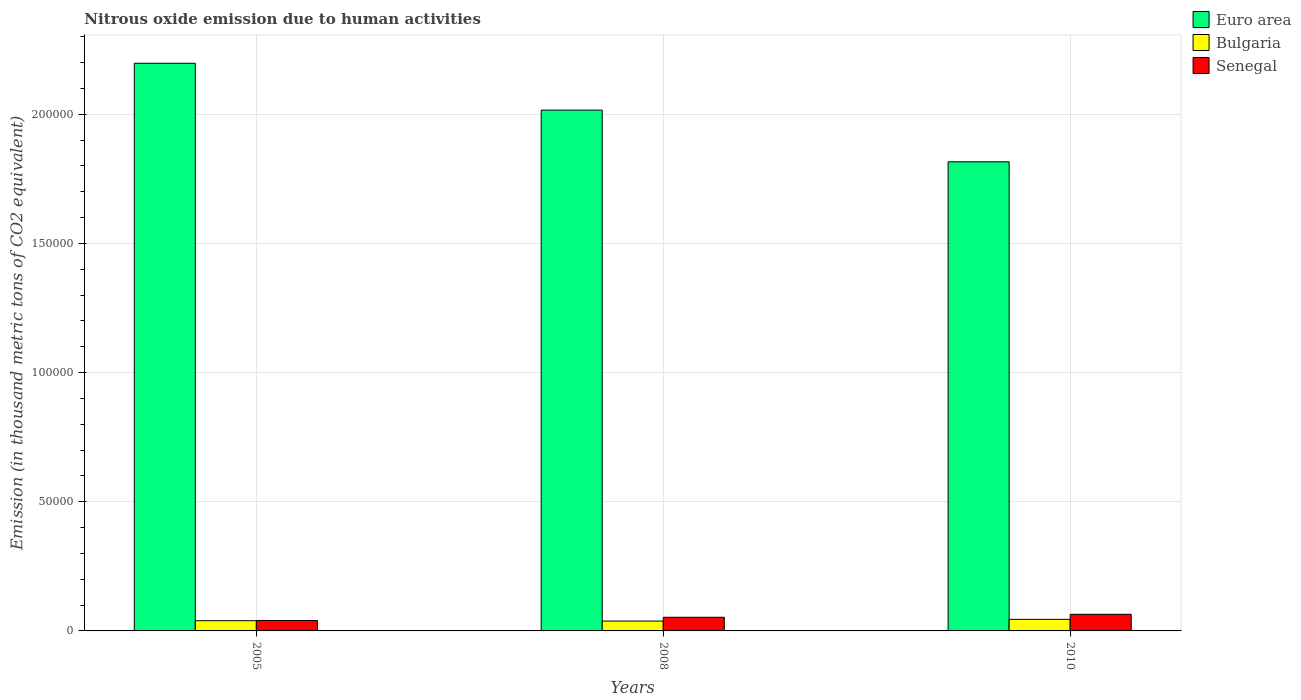Are the number of bars per tick equal to the number of legend labels?
Your response must be concise. Yes. Are the number of bars on each tick of the X-axis equal?
Make the answer very short. Yes. What is the label of the 2nd group of bars from the left?
Make the answer very short. 2008. What is the amount of nitrous oxide emitted in Bulgaria in 2008?
Offer a very short reply. 3815.2. Across all years, what is the maximum amount of nitrous oxide emitted in Senegal?
Offer a very short reply. 6433. Across all years, what is the minimum amount of nitrous oxide emitted in Senegal?
Give a very brief answer. 4042.4. What is the total amount of nitrous oxide emitted in Senegal in the graph?
Your answer should be very brief. 1.58e+04. What is the difference between the amount of nitrous oxide emitted in Euro area in 2005 and that in 2010?
Your answer should be very brief. 3.82e+04. What is the difference between the amount of nitrous oxide emitted in Bulgaria in 2008 and the amount of nitrous oxide emitted in Senegal in 2010?
Give a very brief answer. -2617.8. What is the average amount of nitrous oxide emitted in Senegal per year?
Offer a very short reply. 5252.03. In the year 2010, what is the difference between the amount of nitrous oxide emitted in Senegal and amount of nitrous oxide emitted in Euro area?
Your response must be concise. -1.75e+05. What is the ratio of the amount of nitrous oxide emitted in Bulgaria in 2008 to that in 2010?
Provide a succinct answer. 0.85. What is the difference between the highest and the second highest amount of nitrous oxide emitted in Euro area?
Give a very brief answer. 1.81e+04. What is the difference between the highest and the lowest amount of nitrous oxide emitted in Euro area?
Offer a terse response. 3.82e+04. In how many years, is the amount of nitrous oxide emitted in Bulgaria greater than the average amount of nitrous oxide emitted in Bulgaria taken over all years?
Keep it short and to the point. 1. Is the sum of the amount of nitrous oxide emitted in Euro area in 2005 and 2008 greater than the maximum amount of nitrous oxide emitted in Senegal across all years?
Offer a very short reply. Yes. What does the 1st bar from the right in 2008 represents?
Keep it short and to the point. Senegal. Is it the case that in every year, the sum of the amount of nitrous oxide emitted in Bulgaria and amount of nitrous oxide emitted in Senegal is greater than the amount of nitrous oxide emitted in Euro area?
Give a very brief answer. No. Are all the bars in the graph horizontal?
Make the answer very short. No. How many years are there in the graph?
Provide a short and direct response. 3. Where does the legend appear in the graph?
Offer a very short reply. Top right. How are the legend labels stacked?
Offer a terse response. Vertical. What is the title of the graph?
Offer a terse response. Nitrous oxide emission due to human activities. Does "Canada" appear as one of the legend labels in the graph?
Your response must be concise. No. What is the label or title of the Y-axis?
Offer a terse response. Emission (in thousand metric tons of CO2 equivalent). What is the Emission (in thousand metric tons of CO2 equivalent) in Euro area in 2005?
Ensure brevity in your answer.  2.20e+05. What is the Emission (in thousand metric tons of CO2 equivalent) of Bulgaria in 2005?
Offer a very short reply. 3951.9. What is the Emission (in thousand metric tons of CO2 equivalent) in Senegal in 2005?
Provide a succinct answer. 4042.4. What is the Emission (in thousand metric tons of CO2 equivalent) of Euro area in 2008?
Offer a very short reply. 2.02e+05. What is the Emission (in thousand metric tons of CO2 equivalent) of Bulgaria in 2008?
Offer a very short reply. 3815.2. What is the Emission (in thousand metric tons of CO2 equivalent) in Senegal in 2008?
Provide a succinct answer. 5280.7. What is the Emission (in thousand metric tons of CO2 equivalent) in Euro area in 2010?
Your answer should be compact. 1.82e+05. What is the Emission (in thousand metric tons of CO2 equivalent) of Bulgaria in 2010?
Keep it short and to the point. 4479.2. What is the Emission (in thousand metric tons of CO2 equivalent) in Senegal in 2010?
Make the answer very short. 6433. Across all years, what is the maximum Emission (in thousand metric tons of CO2 equivalent) of Euro area?
Provide a short and direct response. 2.20e+05. Across all years, what is the maximum Emission (in thousand metric tons of CO2 equivalent) in Bulgaria?
Your answer should be compact. 4479.2. Across all years, what is the maximum Emission (in thousand metric tons of CO2 equivalent) of Senegal?
Provide a short and direct response. 6433. Across all years, what is the minimum Emission (in thousand metric tons of CO2 equivalent) of Euro area?
Offer a terse response. 1.82e+05. Across all years, what is the minimum Emission (in thousand metric tons of CO2 equivalent) of Bulgaria?
Offer a terse response. 3815.2. Across all years, what is the minimum Emission (in thousand metric tons of CO2 equivalent) in Senegal?
Provide a succinct answer. 4042.4. What is the total Emission (in thousand metric tons of CO2 equivalent) of Euro area in the graph?
Make the answer very short. 6.03e+05. What is the total Emission (in thousand metric tons of CO2 equivalent) in Bulgaria in the graph?
Keep it short and to the point. 1.22e+04. What is the total Emission (in thousand metric tons of CO2 equivalent) in Senegal in the graph?
Provide a succinct answer. 1.58e+04. What is the difference between the Emission (in thousand metric tons of CO2 equivalent) in Euro area in 2005 and that in 2008?
Provide a succinct answer. 1.81e+04. What is the difference between the Emission (in thousand metric tons of CO2 equivalent) in Bulgaria in 2005 and that in 2008?
Your response must be concise. 136.7. What is the difference between the Emission (in thousand metric tons of CO2 equivalent) in Senegal in 2005 and that in 2008?
Ensure brevity in your answer.  -1238.3. What is the difference between the Emission (in thousand metric tons of CO2 equivalent) of Euro area in 2005 and that in 2010?
Keep it short and to the point. 3.82e+04. What is the difference between the Emission (in thousand metric tons of CO2 equivalent) in Bulgaria in 2005 and that in 2010?
Ensure brevity in your answer.  -527.3. What is the difference between the Emission (in thousand metric tons of CO2 equivalent) of Senegal in 2005 and that in 2010?
Ensure brevity in your answer.  -2390.6. What is the difference between the Emission (in thousand metric tons of CO2 equivalent) in Euro area in 2008 and that in 2010?
Your answer should be very brief. 2.00e+04. What is the difference between the Emission (in thousand metric tons of CO2 equivalent) in Bulgaria in 2008 and that in 2010?
Ensure brevity in your answer.  -664. What is the difference between the Emission (in thousand metric tons of CO2 equivalent) of Senegal in 2008 and that in 2010?
Provide a short and direct response. -1152.3. What is the difference between the Emission (in thousand metric tons of CO2 equivalent) in Euro area in 2005 and the Emission (in thousand metric tons of CO2 equivalent) in Bulgaria in 2008?
Make the answer very short. 2.16e+05. What is the difference between the Emission (in thousand metric tons of CO2 equivalent) of Euro area in 2005 and the Emission (in thousand metric tons of CO2 equivalent) of Senegal in 2008?
Provide a succinct answer. 2.14e+05. What is the difference between the Emission (in thousand metric tons of CO2 equivalent) of Bulgaria in 2005 and the Emission (in thousand metric tons of CO2 equivalent) of Senegal in 2008?
Make the answer very short. -1328.8. What is the difference between the Emission (in thousand metric tons of CO2 equivalent) of Euro area in 2005 and the Emission (in thousand metric tons of CO2 equivalent) of Bulgaria in 2010?
Your answer should be very brief. 2.15e+05. What is the difference between the Emission (in thousand metric tons of CO2 equivalent) in Euro area in 2005 and the Emission (in thousand metric tons of CO2 equivalent) in Senegal in 2010?
Offer a terse response. 2.13e+05. What is the difference between the Emission (in thousand metric tons of CO2 equivalent) of Bulgaria in 2005 and the Emission (in thousand metric tons of CO2 equivalent) of Senegal in 2010?
Your response must be concise. -2481.1. What is the difference between the Emission (in thousand metric tons of CO2 equivalent) of Euro area in 2008 and the Emission (in thousand metric tons of CO2 equivalent) of Bulgaria in 2010?
Keep it short and to the point. 1.97e+05. What is the difference between the Emission (in thousand metric tons of CO2 equivalent) of Euro area in 2008 and the Emission (in thousand metric tons of CO2 equivalent) of Senegal in 2010?
Keep it short and to the point. 1.95e+05. What is the difference between the Emission (in thousand metric tons of CO2 equivalent) of Bulgaria in 2008 and the Emission (in thousand metric tons of CO2 equivalent) of Senegal in 2010?
Offer a terse response. -2617.8. What is the average Emission (in thousand metric tons of CO2 equivalent) in Euro area per year?
Provide a short and direct response. 2.01e+05. What is the average Emission (in thousand metric tons of CO2 equivalent) in Bulgaria per year?
Provide a short and direct response. 4082.1. What is the average Emission (in thousand metric tons of CO2 equivalent) in Senegal per year?
Give a very brief answer. 5252.03. In the year 2005, what is the difference between the Emission (in thousand metric tons of CO2 equivalent) in Euro area and Emission (in thousand metric tons of CO2 equivalent) in Bulgaria?
Provide a succinct answer. 2.16e+05. In the year 2005, what is the difference between the Emission (in thousand metric tons of CO2 equivalent) of Euro area and Emission (in thousand metric tons of CO2 equivalent) of Senegal?
Provide a succinct answer. 2.16e+05. In the year 2005, what is the difference between the Emission (in thousand metric tons of CO2 equivalent) of Bulgaria and Emission (in thousand metric tons of CO2 equivalent) of Senegal?
Your answer should be very brief. -90.5. In the year 2008, what is the difference between the Emission (in thousand metric tons of CO2 equivalent) in Euro area and Emission (in thousand metric tons of CO2 equivalent) in Bulgaria?
Give a very brief answer. 1.98e+05. In the year 2008, what is the difference between the Emission (in thousand metric tons of CO2 equivalent) in Euro area and Emission (in thousand metric tons of CO2 equivalent) in Senegal?
Offer a very short reply. 1.96e+05. In the year 2008, what is the difference between the Emission (in thousand metric tons of CO2 equivalent) in Bulgaria and Emission (in thousand metric tons of CO2 equivalent) in Senegal?
Keep it short and to the point. -1465.5. In the year 2010, what is the difference between the Emission (in thousand metric tons of CO2 equivalent) of Euro area and Emission (in thousand metric tons of CO2 equivalent) of Bulgaria?
Provide a succinct answer. 1.77e+05. In the year 2010, what is the difference between the Emission (in thousand metric tons of CO2 equivalent) of Euro area and Emission (in thousand metric tons of CO2 equivalent) of Senegal?
Make the answer very short. 1.75e+05. In the year 2010, what is the difference between the Emission (in thousand metric tons of CO2 equivalent) in Bulgaria and Emission (in thousand metric tons of CO2 equivalent) in Senegal?
Provide a short and direct response. -1953.8. What is the ratio of the Emission (in thousand metric tons of CO2 equivalent) of Euro area in 2005 to that in 2008?
Keep it short and to the point. 1.09. What is the ratio of the Emission (in thousand metric tons of CO2 equivalent) of Bulgaria in 2005 to that in 2008?
Offer a terse response. 1.04. What is the ratio of the Emission (in thousand metric tons of CO2 equivalent) of Senegal in 2005 to that in 2008?
Keep it short and to the point. 0.77. What is the ratio of the Emission (in thousand metric tons of CO2 equivalent) in Euro area in 2005 to that in 2010?
Make the answer very short. 1.21. What is the ratio of the Emission (in thousand metric tons of CO2 equivalent) in Bulgaria in 2005 to that in 2010?
Your answer should be compact. 0.88. What is the ratio of the Emission (in thousand metric tons of CO2 equivalent) in Senegal in 2005 to that in 2010?
Provide a succinct answer. 0.63. What is the ratio of the Emission (in thousand metric tons of CO2 equivalent) of Euro area in 2008 to that in 2010?
Your answer should be very brief. 1.11. What is the ratio of the Emission (in thousand metric tons of CO2 equivalent) in Bulgaria in 2008 to that in 2010?
Your response must be concise. 0.85. What is the ratio of the Emission (in thousand metric tons of CO2 equivalent) in Senegal in 2008 to that in 2010?
Your answer should be compact. 0.82. What is the difference between the highest and the second highest Emission (in thousand metric tons of CO2 equivalent) of Euro area?
Your answer should be very brief. 1.81e+04. What is the difference between the highest and the second highest Emission (in thousand metric tons of CO2 equivalent) in Bulgaria?
Make the answer very short. 527.3. What is the difference between the highest and the second highest Emission (in thousand metric tons of CO2 equivalent) in Senegal?
Your answer should be very brief. 1152.3. What is the difference between the highest and the lowest Emission (in thousand metric tons of CO2 equivalent) in Euro area?
Keep it short and to the point. 3.82e+04. What is the difference between the highest and the lowest Emission (in thousand metric tons of CO2 equivalent) in Bulgaria?
Provide a short and direct response. 664. What is the difference between the highest and the lowest Emission (in thousand metric tons of CO2 equivalent) of Senegal?
Provide a succinct answer. 2390.6. 